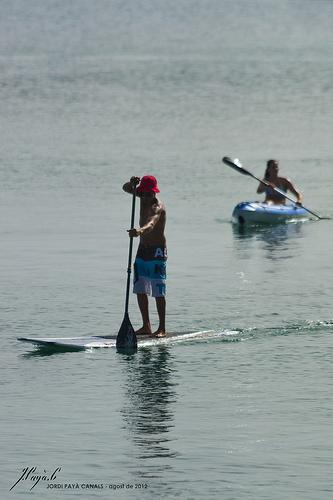Question: why is it so bright?
Choices:
A. A lamp.
B. A candle.
C. Sunny.
D. The moon.
Answer with the letter. Answer: C Question: what is on the man's head?
Choices:
A. The hat.
B. The visor.
C. The headband.
D. The sunglasses.
Answer with the letter. Answer: A Question: what is the woman doing?
Choices:
A. Swimming.
B. Surfing.
C. Kayaking.
D. Diving.
Answer with the letter. Answer: C Question: who is standing?
Choices:
A. The child.
B. The woman.
C. The man.
D. The boy.
Answer with the letter. Answer: C 